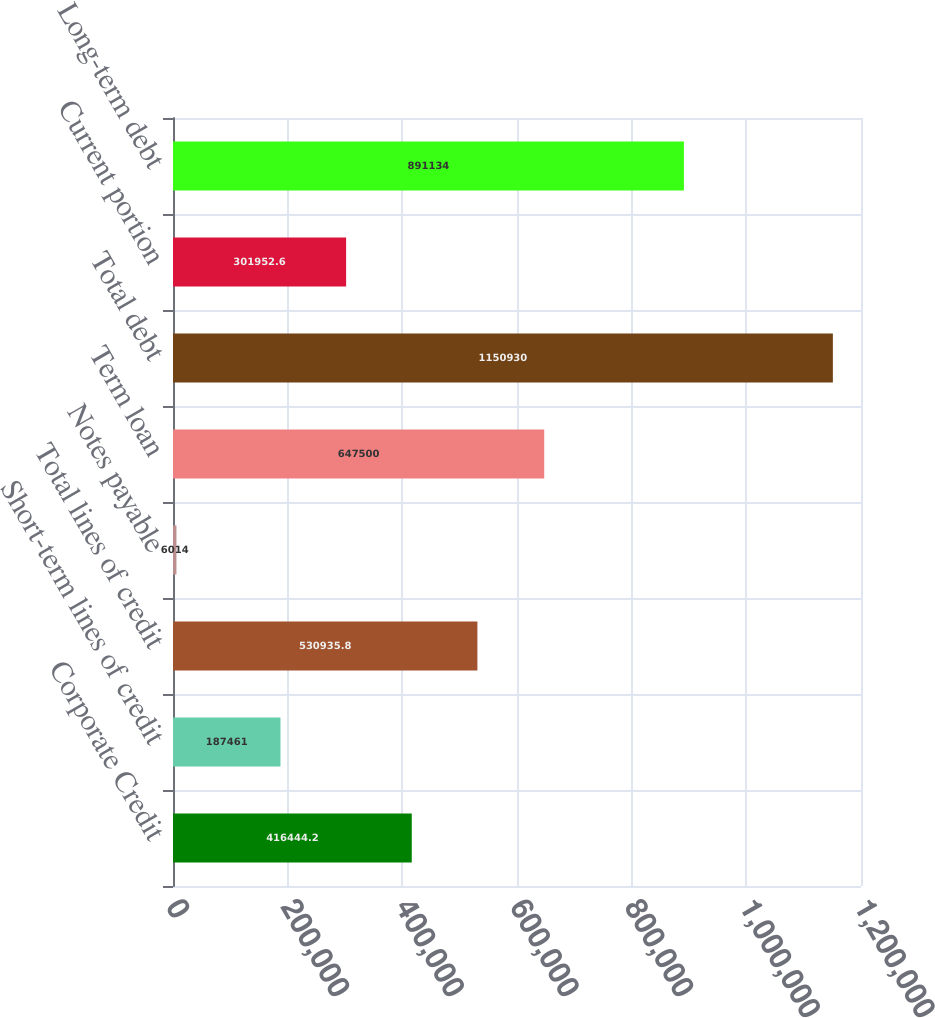Convert chart. <chart><loc_0><loc_0><loc_500><loc_500><bar_chart><fcel>Corporate Credit<fcel>Short-term lines of credit<fcel>Total lines of credit<fcel>Notes payable<fcel>Term loan<fcel>Total debt<fcel>Current portion<fcel>Long-term debt<nl><fcel>416444<fcel>187461<fcel>530936<fcel>6014<fcel>647500<fcel>1.15093e+06<fcel>301953<fcel>891134<nl></chart> 